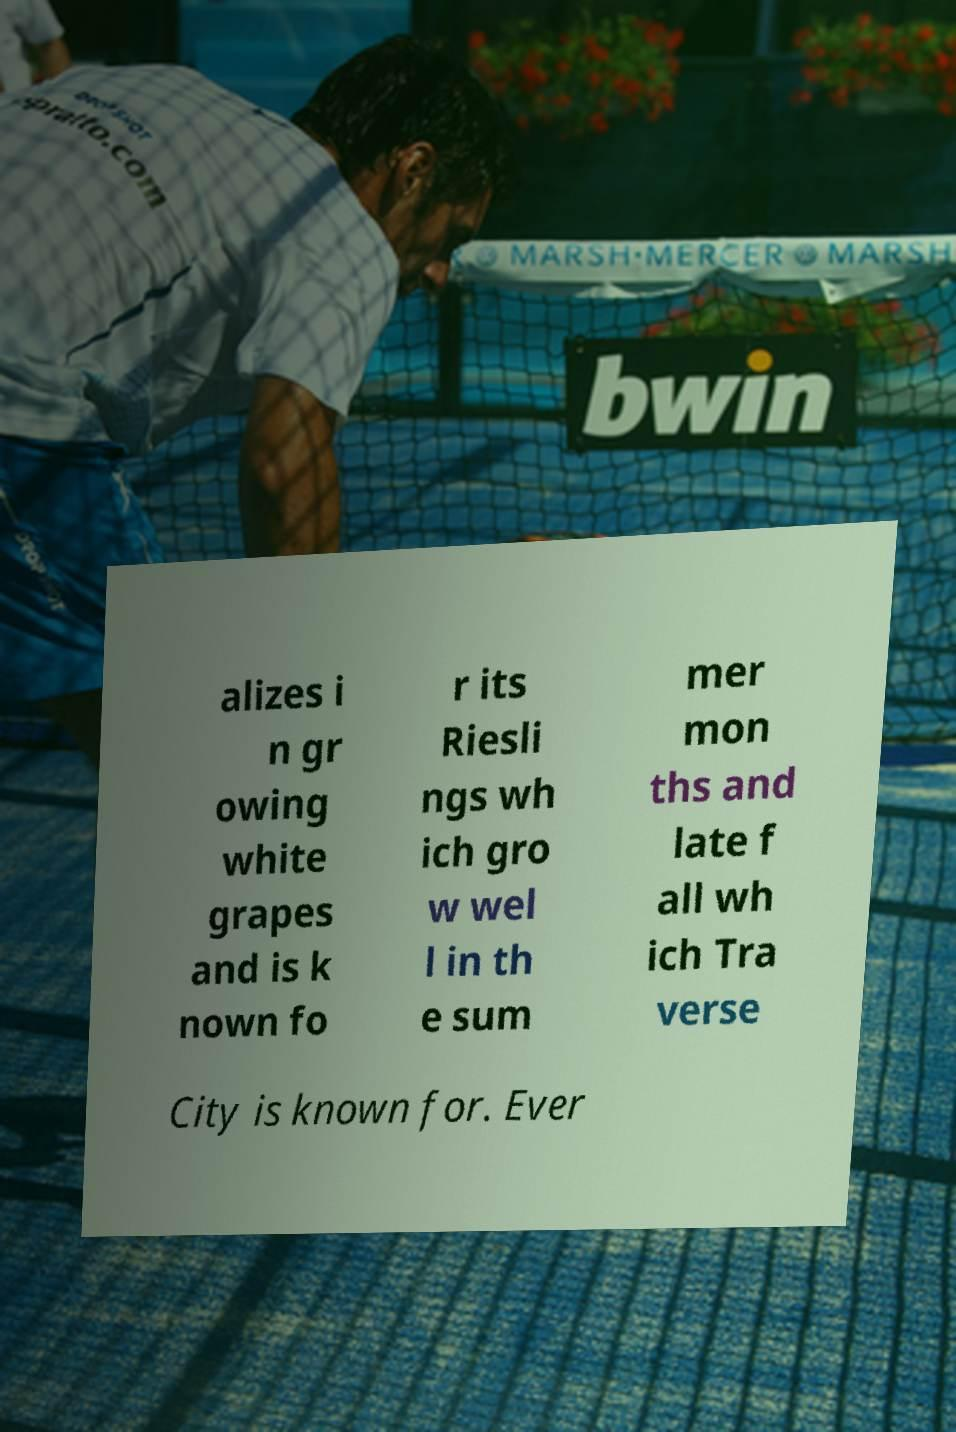Can you read and provide the text displayed in the image?This photo seems to have some interesting text. Can you extract and type it out for me? alizes i n gr owing white grapes and is k nown fo r its Riesli ngs wh ich gro w wel l in th e sum mer mon ths and late f all wh ich Tra verse City is known for. Ever 